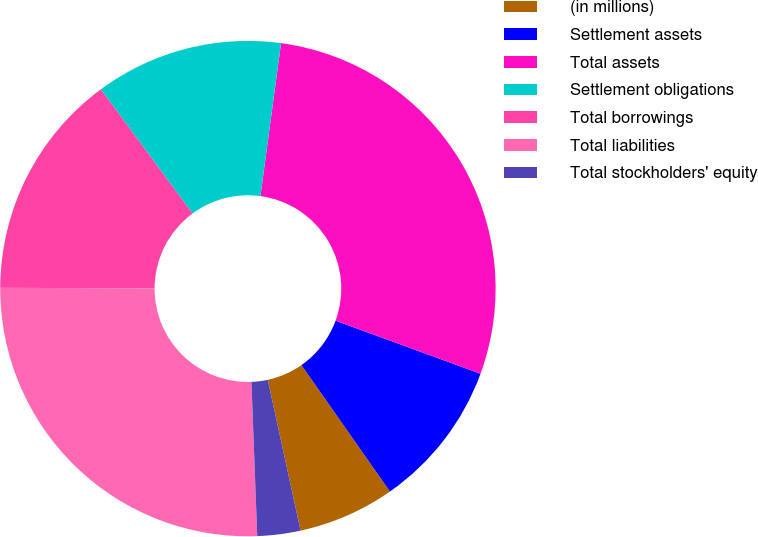Convert chart. <chart><loc_0><loc_0><loc_500><loc_500><pie_chart><fcel>(in millions)<fcel>Settlement assets<fcel>Total assets<fcel>Settlement obligations<fcel>Total borrowings<fcel>Total liabilities<fcel>Total stockholders' equity<nl><fcel>6.31%<fcel>9.7%<fcel>28.45%<fcel>12.26%<fcel>14.83%<fcel>25.65%<fcel>2.81%<nl></chart> 